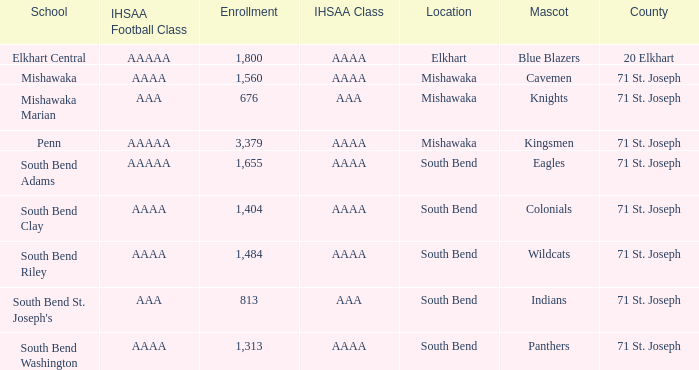What location has an enrollment greater than 1,313, and kingsmen as the mascot? Mishawaka. 